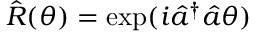Convert formula to latex. <formula><loc_0><loc_0><loc_500><loc_500>\hat { R } ( \theta ) = \exp ( i \hat { a } ^ { \dagger } \hat { a } \theta )</formula> 